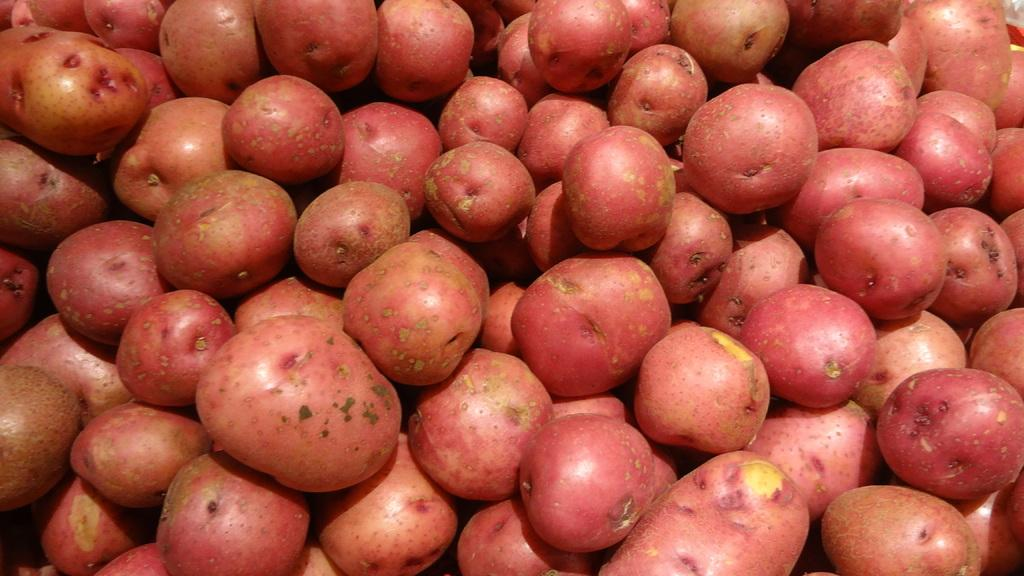What type of food is present in the image? There are sweet potatoes in the image. What type of verse can be heard being recited by the dolls in the image? There are no dolls present in the image, and therefore no verses being recited. 